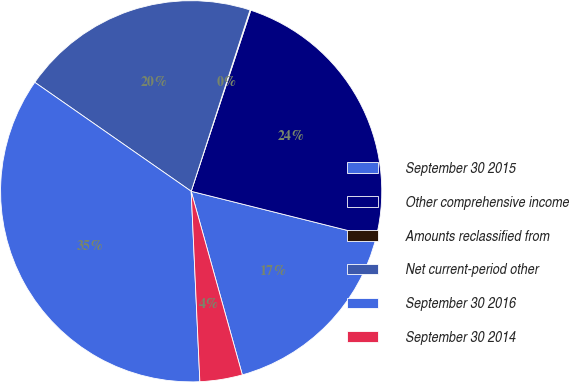<chart> <loc_0><loc_0><loc_500><loc_500><pie_chart><fcel>September 30 2015<fcel>Other comprehensive income<fcel>Amounts reclassified from<fcel>Net current-period other<fcel>September 30 2016<fcel>September 30 2014<nl><fcel>16.77%<fcel>23.84%<fcel>0.07%<fcel>20.31%<fcel>35.41%<fcel>3.6%<nl></chart> 